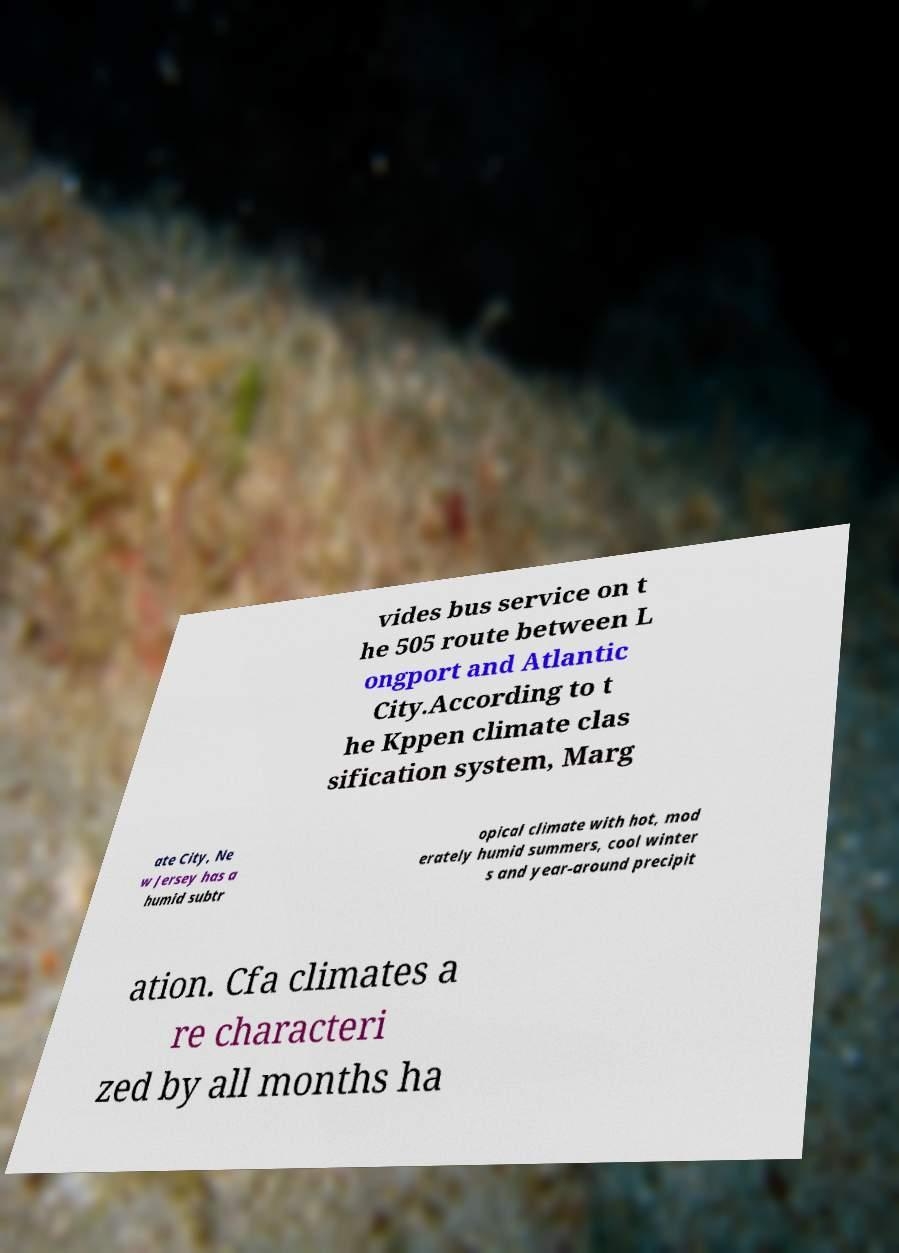Please read and relay the text visible in this image. What does it say? vides bus service on t he 505 route between L ongport and Atlantic City.According to t he Kppen climate clas sification system, Marg ate City, Ne w Jersey has a humid subtr opical climate with hot, mod erately humid summers, cool winter s and year-around precipit ation. Cfa climates a re characteri zed by all months ha 